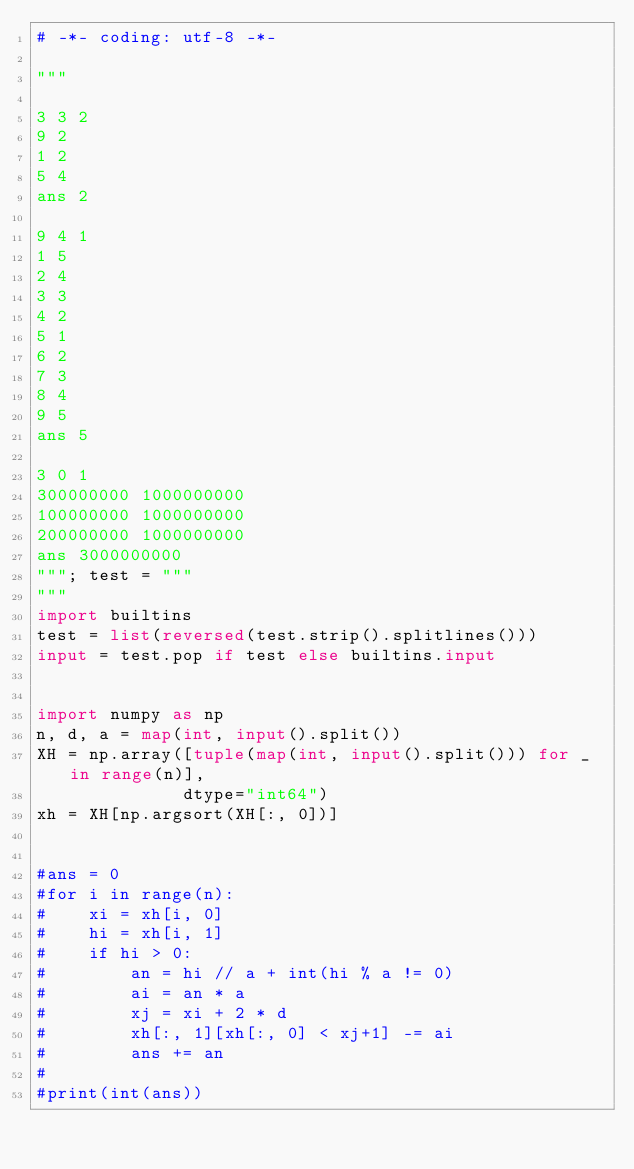<code> <loc_0><loc_0><loc_500><loc_500><_Python_># -*- coding: utf-8 -*-

"""

3 3 2
9 2
1 2
5 4
ans 2

9 4 1
1 5
2 4
3 3
4 2
5 1
6 2
7 3
8 4
9 5
ans 5

3 0 1
300000000 1000000000
100000000 1000000000
200000000 1000000000
ans 3000000000
"""; test = """
"""
import builtins
test = list(reversed(test.strip().splitlines()))
input = test.pop if test else builtins.input


import numpy as np
n, d, a = map(int, input().split())
XH = np.array([tuple(map(int, input().split())) for _ in range(n)], 
              dtype="int64")
xh = XH[np.argsort(XH[:, 0])]


#ans = 0
#for i in range(n):
#    xi = xh[i, 0]
#    hi = xh[i, 1]
#    if hi > 0:
#        an = hi // a + int(hi % a != 0)
#        ai = an * a
#        xj = xi + 2 * d
#        xh[:, 1][xh[:, 0] < xj+1] -= ai
#        ans += an
#    
#print(int(ans))

</code> 